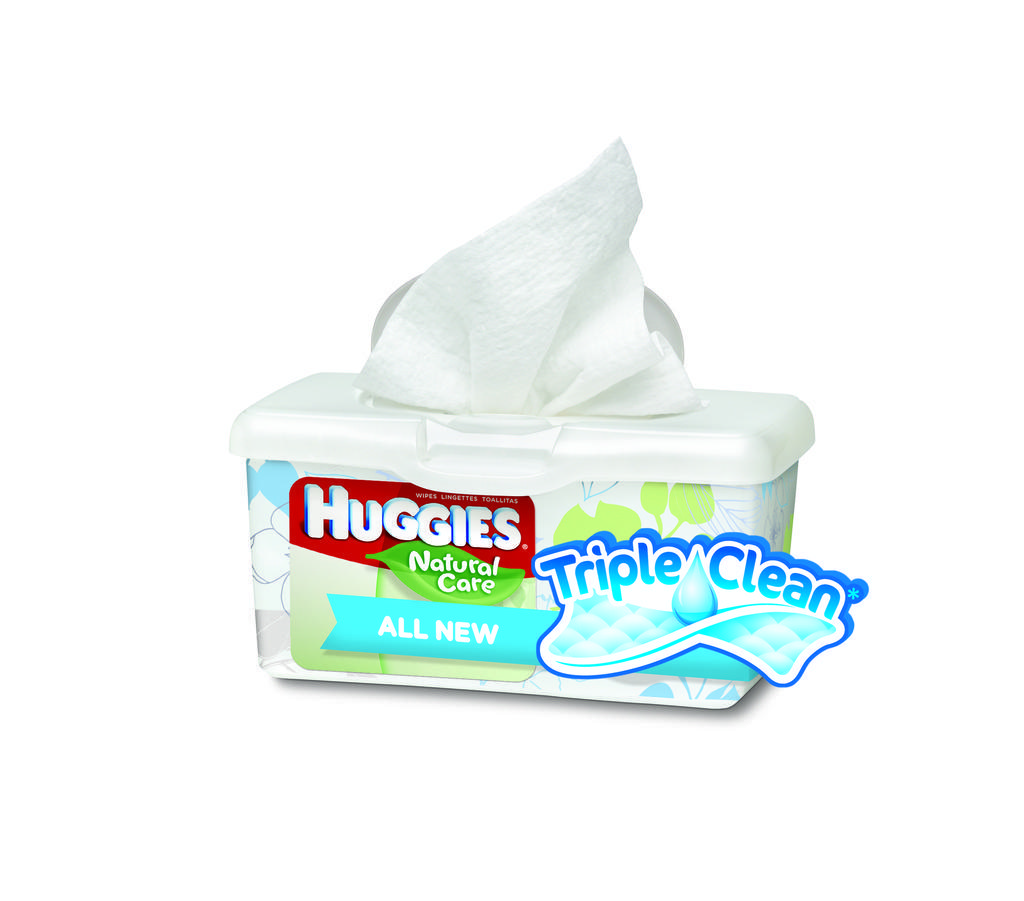How would you summarize this image in a sentence or two? In this picture we can see Huggies baby wipes in a white box. 